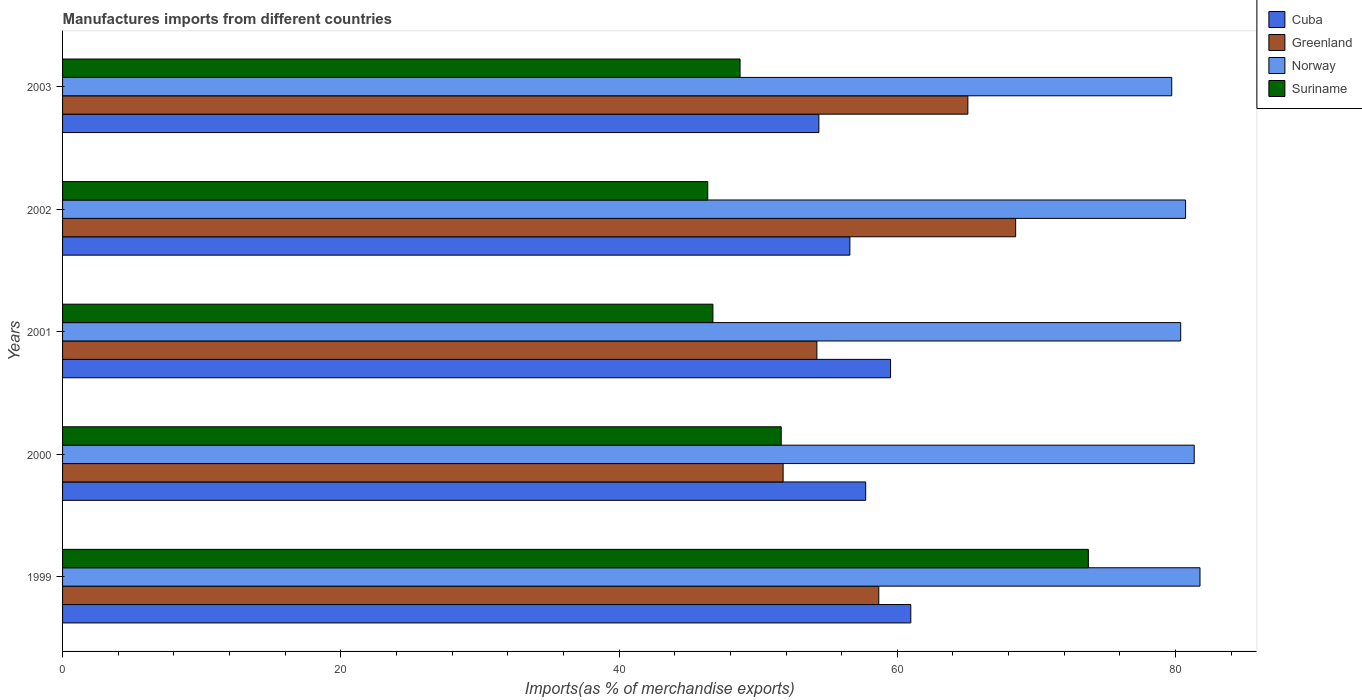Are the number of bars per tick equal to the number of legend labels?
Keep it short and to the point. Yes. How many bars are there on the 1st tick from the top?
Your answer should be very brief. 4. How many bars are there on the 2nd tick from the bottom?
Make the answer very short. 4. What is the label of the 5th group of bars from the top?
Ensure brevity in your answer.  1999. In how many cases, is the number of bars for a given year not equal to the number of legend labels?
Make the answer very short. 0. What is the percentage of imports to different countries in Cuba in 2002?
Keep it short and to the point. 56.59. Across all years, what is the maximum percentage of imports to different countries in Norway?
Ensure brevity in your answer.  81.75. Across all years, what is the minimum percentage of imports to different countries in Cuba?
Your answer should be compact. 54.36. In which year was the percentage of imports to different countries in Cuba maximum?
Keep it short and to the point. 1999. In which year was the percentage of imports to different countries in Cuba minimum?
Ensure brevity in your answer.  2003. What is the total percentage of imports to different countries in Suriname in the graph?
Make the answer very short. 267.2. What is the difference between the percentage of imports to different countries in Suriname in 2002 and that in 2003?
Your answer should be compact. -2.32. What is the difference between the percentage of imports to different countries in Greenland in 2000 and the percentage of imports to different countries in Norway in 2003?
Ensure brevity in your answer.  -27.93. What is the average percentage of imports to different countries in Suriname per year?
Offer a very short reply. 53.44. In the year 2002, what is the difference between the percentage of imports to different countries in Norway and percentage of imports to different countries in Greenland?
Make the answer very short. 12.21. In how many years, is the percentage of imports to different countries in Norway greater than 64 %?
Offer a terse response. 5. What is the ratio of the percentage of imports to different countries in Suriname in 1999 to that in 2000?
Offer a very short reply. 1.43. Is the difference between the percentage of imports to different countries in Norway in 1999 and 2003 greater than the difference between the percentage of imports to different countries in Greenland in 1999 and 2003?
Give a very brief answer. Yes. What is the difference between the highest and the second highest percentage of imports to different countries in Norway?
Keep it short and to the point. 0.41. What is the difference between the highest and the lowest percentage of imports to different countries in Cuba?
Keep it short and to the point. 6.61. What does the 4th bar from the top in 2001 represents?
Provide a short and direct response. Cuba. What does the 3rd bar from the bottom in 1999 represents?
Make the answer very short. Norway. Is it the case that in every year, the sum of the percentage of imports to different countries in Cuba and percentage of imports to different countries in Suriname is greater than the percentage of imports to different countries in Norway?
Make the answer very short. Yes. How many years are there in the graph?
Keep it short and to the point. 5. What is the difference between two consecutive major ticks on the X-axis?
Ensure brevity in your answer.  20. Are the values on the major ticks of X-axis written in scientific E-notation?
Offer a terse response. No. Does the graph contain any zero values?
Provide a succinct answer. No. How many legend labels are there?
Provide a short and direct response. 4. How are the legend labels stacked?
Offer a terse response. Vertical. What is the title of the graph?
Your answer should be compact. Manufactures imports from different countries. What is the label or title of the X-axis?
Keep it short and to the point. Imports(as % of merchandise exports). What is the Imports(as % of merchandise exports) of Cuba in 1999?
Your answer should be very brief. 60.97. What is the Imports(as % of merchandise exports) in Greenland in 1999?
Keep it short and to the point. 58.67. What is the Imports(as % of merchandise exports) of Norway in 1999?
Give a very brief answer. 81.75. What is the Imports(as % of merchandise exports) in Suriname in 1999?
Provide a short and direct response. 73.73. What is the Imports(as % of merchandise exports) of Cuba in 2000?
Provide a succinct answer. 57.72. What is the Imports(as % of merchandise exports) of Greenland in 2000?
Provide a succinct answer. 51.79. What is the Imports(as % of merchandise exports) of Norway in 2000?
Offer a very short reply. 81.34. What is the Imports(as % of merchandise exports) of Suriname in 2000?
Provide a short and direct response. 51.65. What is the Imports(as % of merchandise exports) of Cuba in 2001?
Offer a very short reply. 59.51. What is the Imports(as % of merchandise exports) in Greenland in 2001?
Make the answer very short. 54.22. What is the Imports(as % of merchandise exports) of Norway in 2001?
Offer a terse response. 80.37. What is the Imports(as % of merchandise exports) in Suriname in 2001?
Offer a terse response. 46.74. What is the Imports(as % of merchandise exports) of Cuba in 2002?
Keep it short and to the point. 56.59. What is the Imports(as % of merchandise exports) in Greenland in 2002?
Ensure brevity in your answer.  68.5. What is the Imports(as % of merchandise exports) in Norway in 2002?
Your answer should be very brief. 80.72. What is the Imports(as % of merchandise exports) in Suriname in 2002?
Keep it short and to the point. 46.37. What is the Imports(as % of merchandise exports) in Cuba in 2003?
Provide a short and direct response. 54.36. What is the Imports(as % of merchandise exports) of Greenland in 2003?
Offer a terse response. 65.07. What is the Imports(as % of merchandise exports) of Norway in 2003?
Offer a very short reply. 79.72. What is the Imports(as % of merchandise exports) in Suriname in 2003?
Keep it short and to the point. 48.7. Across all years, what is the maximum Imports(as % of merchandise exports) in Cuba?
Offer a terse response. 60.97. Across all years, what is the maximum Imports(as % of merchandise exports) in Greenland?
Give a very brief answer. 68.5. Across all years, what is the maximum Imports(as % of merchandise exports) of Norway?
Give a very brief answer. 81.75. Across all years, what is the maximum Imports(as % of merchandise exports) in Suriname?
Ensure brevity in your answer.  73.73. Across all years, what is the minimum Imports(as % of merchandise exports) in Cuba?
Provide a short and direct response. 54.36. Across all years, what is the minimum Imports(as % of merchandise exports) in Greenland?
Your answer should be very brief. 51.79. Across all years, what is the minimum Imports(as % of merchandise exports) in Norway?
Ensure brevity in your answer.  79.72. Across all years, what is the minimum Imports(as % of merchandise exports) in Suriname?
Make the answer very short. 46.37. What is the total Imports(as % of merchandise exports) of Cuba in the graph?
Make the answer very short. 289.15. What is the total Imports(as % of merchandise exports) in Greenland in the graph?
Provide a succinct answer. 298.25. What is the total Imports(as % of merchandise exports) in Norway in the graph?
Your response must be concise. 403.9. What is the total Imports(as % of merchandise exports) of Suriname in the graph?
Keep it short and to the point. 267.2. What is the difference between the Imports(as % of merchandise exports) of Cuba in 1999 and that in 2000?
Give a very brief answer. 3.24. What is the difference between the Imports(as % of merchandise exports) in Greenland in 1999 and that in 2000?
Your answer should be very brief. 6.88. What is the difference between the Imports(as % of merchandise exports) of Norway in 1999 and that in 2000?
Keep it short and to the point. 0.41. What is the difference between the Imports(as % of merchandise exports) of Suriname in 1999 and that in 2000?
Make the answer very short. 22.08. What is the difference between the Imports(as % of merchandise exports) in Cuba in 1999 and that in 2001?
Your answer should be compact. 1.45. What is the difference between the Imports(as % of merchandise exports) in Greenland in 1999 and that in 2001?
Give a very brief answer. 4.45. What is the difference between the Imports(as % of merchandise exports) in Norway in 1999 and that in 2001?
Give a very brief answer. 1.39. What is the difference between the Imports(as % of merchandise exports) in Suriname in 1999 and that in 2001?
Make the answer very short. 26.99. What is the difference between the Imports(as % of merchandise exports) in Cuba in 1999 and that in 2002?
Make the answer very short. 4.38. What is the difference between the Imports(as % of merchandise exports) in Greenland in 1999 and that in 2002?
Give a very brief answer. -9.84. What is the difference between the Imports(as % of merchandise exports) in Norway in 1999 and that in 2002?
Offer a terse response. 1.04. What is the difference between the Imports(as % of merchandise exports) in Suriname in 1999 and that in 2002?
Keep it short and to the point. 27.36. What is the difference between the Imports(as % of merchandise exports) in Cuba in 1999 and that in 2003?
Offer a very short reply. 6.61. What is the difference between the Imports(as % of merchandise exports) of Greenland in 1999 and that in 2003?
Make the answer very short. -6.4. What is the difference between the Imports(as % of merchandise exports) of Norway in 1999 and that in 2003?
Offer a very short reply. 2.03. What is the difference between the Imports(as % of merchandise exports) in Suriname in 1999 and that in 2003?
Give a very brief answer. 25.03. What is the difference between the Imports(as % of merchandise exports) in Cuba in 2000 and that in 2001?
Keep it short and to the point. -1.79. What is the difference between the Imports(as % of merchandise exports) of Greenland in 2000 and that in 2001?
Your response must be concise. -2.43. What is the difference between the Imports(as % of merchandise exports) in Norway in 2000 and that in 2001?
Give a very brief answer. 0.97. What is the difference between the Imports(as % of merchandise exports) of Suriname in 2000 and that in 2001?
Keep it short and to the point. 4.91. What is the difference between the Imports(as % of merchandise exports) of Cuba in 2000 and that in 2002?
Give a very brief answer. 1.14. What is the difference between the Imports(as % of merchandise exports) of Greenland in 2000 and that in 2002?
Provide a short and direct response. -16.71. What is the difference between the Imports(as % of merchandise exports) in Norway in 2000 and that in 2002?
Provide a succinct answer. 0.62. What is the difference between the Imports(as % of merchandise exports) of Suriname in 2000 and that in 2002?
Offer a terse response. 5.28. What is the difference between the Imports(as % of merchandise exports) of Cuba in 2000 and that in 2003?
Give a very brief answer. 3.36. What is the difference between the Imports(as % of merchandise exports) in Greenland in 2000 and that in 2003?
Your answer should be very brief. -13.28. What is the difference between the Imports(as % of merchandise exports) in Norway in 2000 and that in 2003?
Your answer should be very brief. 1.62. What is the difference between the Imports(as % of merchandise exports) of Suriname in 2000 and that in 2003?
Your response must be concise. 2.96. What is the difference between the Imports(as % of merchandise exports) in Cuba in 2001 and that in 2002?
Your response must be concise. 2.93. What is the difference between the Imports(as % of merchandise exports) in Greenland in 2001 and that in 2002?
Offer a very short reply. -14.29. What is the difference between the Imports(as % of merchandise exports) of Norway in 2001 and that in 2002?
Make the answer very short. -0.35. What is the difference between the Imports(as % of merchandise exports) in Suriname in 2001 and that in 2002?
Offer a terse response. 0.37. What is the difference between the Imports(as % of merchandise exports) in Cuba in 2001 and that in 2003?
Offer a very short reply. 5.15. What is the difference between the Imports(as % of merchandise exports) in Greenland in 2001 and that in 2003?
Give a very brief answer. -10.85. What is the difference between the Imports(as % of merchandise exports) of Norway in 2001 and that in 2003?
Keep it short and to the point. 0.64. What is the difference between the Imports(as % of merchandise exports) of Suriname in 2001 and that in 2003?
Your answer should be compact. -1.95. What is the difference between the Imports(as % of merchandise exports) of Cuba in 2002 and that in 2003?
Your answer should be compact. 2.23. What is the difference between the Imports(as % of merchandise exports) in Greenland in 2002 and that in 2003?
Give a very brief answer. 3.44. What is the difference between the Imports(as % of merchandise exports) in Suriname in 2002 and that in 2003?
Your answer should be compact. -2.32. What is the difference between the Imports(as % of merchandise exports) in Cuba in 1999 and the Imports(as % of merchandise exports) in Greenland in 2000?
Keep it short and to the point. 9.18. What is the difference between the Imports(as % of merchandise exports) of Cuba in 1999 and the Imports(as % of merchandise exports) of Norway in 2000?
Ensure brevity in your answer.  -20.37. What is the difference between the Imports(as % of merchandise exports) in Cuba in 1999 and the Imports(as % of merchandise exports) in Suriname in 2000?
Provide a short and direct response. 9.31. What is the difference between the Imports(as % of merchandise exports) of Greenland in 1999 and the Imports(as % of merchandise exports) of Norway in 2000?
Provide a succinct answer. -22.67. What is the difference between the Imports(as % of merchandise exports) in Greenland in 1999 and the Imports(as % of merchandise exports) in Suriname in 2000?
Provide a short and direct response. 7.01. What is the difference between the Imports(as % of merchandise exports) in Norway in 1999 and the Imports(as % of merchandise exports) in Suriname in 2000?
Keep it short and to the point. 30.1. What is the difference between the Imports(as % of merchandise exports) of Cuba in 1999 and the Imports(as % of merchandise exports) of Greenland in 2001?
Keep it short and to the point. 6.75. What is the difference between the Imports(as % of merchandise exports) of Cuba in 1999 and the Imports(as % of merchandise exports) of Norway in 2001?
Your answer should be very brief. -19.4. What is the difference between the Imports(as % of merchandise exports) of Cuba in 1999 and the Imports(as % of merchandise exports) of Suriname in 2001?
Provide a succinct answer. 14.22. What is the difference between the Imports(as % of merchandise exports) of Greenland in 1999 and the Imports(as % of merchandise exports) of Norway in 2001?
Provide a succinct answer. -21.7. What is the difference between the Imports(as % of merchandise exports) in Greenland in 1999 and the Imports(as % of merchandise exports) in Suriname in 2001?
Offer a terse response. 11.92. What is the difference between the Imports(as % of merchandise exports) in Norway in 1999 and the Imports(as % of merchandise exports) in Suriname in 2001?
Give a very brief answer. 35.01. What is the difference between the Imports(as % of merchandise exports) of Cuba in 1999 and the Imports(as % of merchandise exports) of Greenland in 2002?
Give a very brief answer. -7.54. What is the difference between the Imports(as % of merchandise exports) in Cuba in 1999 and the Imports(as % of merchandise exports) in Norway in 2002?
Ensure brevity in your answer.  -19.75. What is the difference between the Imports(as % of merchandise exports) of Cuba in 1999 and the Imports(as % of merchandise exports) of Suriname in 2002?
Offer a very short reply. 14.59. What is the difference between the Imports(as % of merchandise exports) in Greenland in 1999 and the Imports(as % of merchandise exports) in Norway in 2002?
Give a very brief answer. -22.05. What is the difference between the Imports(as % of merchandise exports) in Greenland in 1999 and the Imports(as % of merchandise exports) in Suriname in 2002?
Offer a terse response. 12.29. What is the difference between the Imports(as % of merchandise exports) of Norway in 1999 and the Imports(as % of merchandise exports) of Suriname in 2002?
Offer a terse response. 35.38. What is the difference between the Imports(as % of merchandise exports) of Cuba in 1999 and the Imports(as % of merchandise exports) of Greenland in 2003?
Make the answer very short. -4.1. What is the difference between the Imports(as % of merchandise exports) of Cuba in 1999 and the Imports(as % of merchandise exports) of Norway in 2003?
Provide a short and direct response. -18.76. What is the difference between the Imports(as % of merchandise exports) in Cuba in 1999 and the Imports(as % of merchandise exports) in Suriname in 2003?
Your answer should be compact. 12.27. What is the difference between the Imports(as % of merchandise exports) of Greenland in 1999 and the Imports(as % of merchandise exports) of Norway in 2003?
Your response must be concise. -21.06. What is the difference between the Imports(as % of merchandise exports) of Greenland in 1999 and the Imports(as % of merchandise exports) of Suriname in 2003?
Offer a terse response. 9.97. What is the difference between the Imports(as % of merchandise exports) of Norway in 1999 and the Imports(as % of merchandise exports) of Suriname in 2003?
Give a very brief answer. 33.06. What is the difference between the Imports(as % of merchandise exports) of Cuba in 2000 and the Imports(as % of merchandise exports) of Greenland in 2001?
Offer a very short reply. 3.51. What is the difference between the Imports(as % of merchandise exports) of Cuba in 2000 and the Imports(as % of merchandise exports) of Norway in 2001?
Give a very brief answer. -22.64. What is the difference between the Imports(as % of merchandise exports) of Cuba in 2000 and the Imports(as % of merchandise exports) of Suriname in 2001?
Give a very brief answer. 10.98. What is the difference between the Imports(as % of merchandise exports) in Greenland in 2000 and the Imports(as % of merchandise exports) in Norway in 2001?
Give a very brief answer. -28.58. What is the difference between the Imports(as % of merchandise exports) of Greenland in 2000 and the Imports(as % of merchandise exports) of Suriname in 2001?
Ensure brevity in your answer.  5.05. What is the difference between the Imports(as % of merchandise exports) of Norway in 2000 and the Imports(as % of merchandise exports) of Suriname in 2001?
Provide a succinct answer. 34.6. What is the difference between the Imports(as % of merchandise exports) of Cuba in 2000 and the Imports(as % of merchandise exports) of Greenland in 2002?
Your response must be concise. -10.78. What is the difference between the Imports(as % of merchandise exports) of Cuba in 2000 and the Imports(as % of merchandise exports) of Norway in 2002?
Your answer should be compact. -22.99. What is the difference between the Imports(as % of merchandise exports) of Cuba in 2000 and the Imports(as % of merchandise exports) of Suriname in 2002?
Your response must be concise. 11.35. What is the difference between the Imports(as % of merchandise exports) of Greenland in 2000 and the Imports(as % of merchandise exports) of Norway in 2002?
Provide a succinct answer. -28.93. What is the difference between the Imports(as % of merchandise exports) in Greenland in 2000 and the Imports(as % of merchandise exports) in Suriname in 2002?
Keep it short and to the point. 5.42. What is the difference between the Imports(as % of merchandise exports) of Norway in 2000 and the Imports(as % of merchandise exports) of Suriname in 2002?
Provide a succinct answer. 34.97. What is the difference between the Imports(as % of merchandise exports) in Cuba in 2000 and the Imports(as % of merchandise exports) in Greenland in 2003?
Provide a short and direct response. -7.34. What is the difference between the Imports(as % of merchandise exports) of Cuba in 2000 and the Imports(as % of merchandise exports) of Norway in 2003?
Ensure brevity in your answer.  -22. What is the difference between the Imports(as % of merchandise exports) in Cuba in 2000 and the Imports(as % of merchandise exports) in Suriname in 2003?
Make the answer very short. 9.03. What is the difference between the Imports(as % of merchandise exports) in Greenland in 2000 and the Imports(as % of merchandise exports) in Norway in 2003?
Ensure brevity in your answer.  -27.93. What is the difference between the Imports(as % of merchandise exports) of Greenland in 2000 and the Imports(as % of merchandise exports) of Suriname in 2003?
Keep it short and to the point. 3.09. What is the difference between the Imports(as % of merchandise exports) of Norway in 2000 and the Imports(as % of merchandise exports) of Suriname in 2003?
Make the answer very short. 32.64. What is the difference between the Imports(as % of merchandise exports) in Cuba in 2001 and the Imports(as % of merchandise exports) in Greenland in 2002?
Your answer should be compact. -8.99. What is the difference between the Imports(as % of merchandise exports) in Cuba in 2001 and the Imports(as % of merchandise exports) in Norway in 2002?
Provide a succinct answer. -21.2. What is the difference between the Imports(as % of merchandise exports) of Cuba in 2001 and the Imports(as % of merchandise exports) of Suriname in 2002?
Give a very brief answer. 13.14. What is the difference between the Imports(as % of merchandise exports) of Greenland in 2001 and the Imports(as % of merchandise exports) of Norway in 2002?
Your answer should be very brief. -26.5. What is the difference between the Imports(as % of merchandise exports) of Greenland in 2001 and the Imports(as % of merchandise exports) of Suriname in 2002?
Your response must be concise. 7.84. What is the difference between the Imports(as % of merchandise exports) in Norway in 2001 and the Imports(as % of merchandise exports) in Suriname in 2002?
Make the answer very short. 33.99. What is the difference between the Imports(as % of merchandise exports) of Cuba in 2001 and the Imports(as % of merchandise exports) of Greenland in 2003?
Keep it short and to the point. -5.56. What is the difference between the Imports(as % of merchandise exports) of Cuba in 2001 and the Imports(as % of merchandise exports) of Norway in 2003?
Make the answer very short. -20.21. What is the difference between the Imports(as % of merchandise exports) of Cuba in 2001 and the Imports(as % of merchandise exports) of Suriname in 2003?
Your answer should be very brief. 10.82. What is the difference between the Imports(as % of merchandise exports) in Greenland in 2001 and the Imports(as % of merchandise exports) in Norway in 2003?
Your answer should be compact. -25.51. What is the difference between the Imports(as % of merchandise exports) in Greenland in 2001 and the Imports(as % of merchandise exports) in Suriname in 2003?
Provide a short and direct response. 5.52. What is the difference between the Imports(as % of merchandise exports) in Norway in 2001 and the Imports(as % of merchandise exports) in Suriname in 2003?
Provide a succinct answer. 31.67. What is the difference between the Imports(as % of merchandise exports) in Cuba in 2002 and the Imports(as % of merchandise exports) in Greenland in 2003?
Give a very brief answer. -8.48. What is the difference between the Imports(as % of merchandise exports) of Cuba in 2002 and the Imports(as % of merchandise exports) of Norway in 2003?
Provide a short and direct response. -23.13. What is the difference between the Imports(as % of merchandise exports) in Cuba in 2002 and the Imports(as % of merchandise exports) in Suriname in 2003?
Provide a succinct answer. 7.89. What is the difference between the Imports(as % of merchandise exports) in Greenland in 2002 and the Imports(as % of merchandise exports) in Norway in 2003?
Offer a very short reply. -11.22. What is the difference between the Imports(as % of merchandise exports) of Greenland in 2002 and the Imports(as % of merchandise exports) of Suriname in 2003?
Your answer should be very brief. 19.81. What is the difference between the Imports(as % of merchandise exports) in Norway in 2002 and the Imports(as % of merchandise exports) in Suriname in 2003?
Make the answer very short. 32.02. What is the average Imports(as % of merchandise exports) of Cuba per year?
Provide a succinct answer. 57.83. What is the average Imports(as % of merchandise exports) in Greenland per year?
Provide a succinct answer. 59.65. What is the average Imports(as % of merchandise exports) of Norway per year?
Make the answer very short. 80.78. What is the average Imports(as % of merchandise exports) of Suriname per year?
Your response must be concise. 53.44. In the year 1999, what is the difference between the Imports(as % of merchandise exports) of Cuba and Imports(as % of merchandise exports) of Greenland?
Give a very brief answer. 2.3. In the year 1999, what is the difference between the Imports(as % of merchandise exports) in Cuba and Imports(as % of merchandise exports) in Norway?
Your response must be concise. -20.79. In the year 1999, what is the difference between the Imports(as % of merchandise exports) of Cuba and Imports(as % of merchandise exports) of Suriname?
Provide a succinct answer. -12.76. In the year 1999, what is the difference between the Imports(as % of merchandise exports) of Greenland and Imports(as % of merchandise exports) of Norway?
Your response must be concise. -23.09. In the year 1999, what is the difference between the Imports(as % of merchandise exports) in Greenland and Imports(as % of merchandise exports) in Suriname?
Offer a very short reply. -15.06. In the year 1999, what is the difference between the Imports(as % of merchandise exports) of Norway and Imports(as % of merchandise exports) of Suriname?
Offer a terse response. 8.02. In the year 2000, what is the difference between the Imports(as % of merchandise exports) of Cuba and Imports(as % of merchandise exports) of Greenland?
Make the answer very short. 5.93. In the year 2000, what is the difference between the Imports(as % of merchandise exports) in Cuba and Imports(as % of merchandise exports) in Norway?
Offer a terse response. -23.62. In the year 2000, what is the difference between the Imports(as % of merchandise exports) of Cuba and Imports(as % of merchandise exports) of Suriname?
Your response must be concise. 6.07. In the year 2000, what is the difference between the Imports(as % of merchandise exports) of Greenland and Imports(as % of merchandise exports) of Norway?
Give a very brief answer. -29.55. In the year 2000, what is the difference between the Imports(as % of merchandise exports) in Greenland and Imports(as % of merchandise exports) in Suriname?
Make the answer very short. 0.14. In the year 2000, what is the difference between the Imports(as % of merchandise exports) in Norway and Imports(as % of merchandise exports) in Suriname?
Provide a short and direct response. 29.69. In the year 2001, what is the difference between the Imports(as % of merchandise exports) of Cuba and Imports(as % of merchandise exports) of Greenland?
Your response must be concise. 5.3. In the year 2001, what is the difference between the Imports(as % of merchandise exports) of Cuba and Imports(as % of merchandise exports) of Norway?
Your answer should be compact. -20.85. In the year 2001, what is the difference between the Imports(as % of merchandise exports) in Cuba and Imports(as % of merchandise exports) in Suriname?
Keep it short and to the point. 12.77. In the year 2001, what is the difference between the Imports(as % of merchandise exports) of Greenland and Imports(as % of merchandise exports) of Norway?
Provide a succinct answer. -26.15. In the year 2001, what is the difference between the Imports(as % of merchandise exports) of Greenland and Imports(as % of merchandise exports) of Suriname?
Offer a terse response. 7.47. In the year 2001, what is the difference between the Imports(as % of merchandise exports) of Norway and Imports(as % of merchandise exports) of Suriname?
Keep it short and to the point. 33.62. In the year 2002, what is the difference between the Imports(as % of merchandise exports) in Cuba and Imports(as % of merchandise exports) in Greenland?
Offer a terse response. -11.92. In the year 2002, what is the difference between the Imports(as % of merchandise exports) in Cuba and Imports(as % of merchandise exports) in Norway?
Your answer should be very brief. -24.13. In the year 2002, what is the difference between the Imports(as % of merchandise exports) of Cuba and Imports(as % of merchandise exports) of Suriname?
Offer a very short reply. 10.21. In the year 2002, what is the difference between the Imports(as % of merchandise exports) in Greenland and Imports(as % of merchandise exports) in Norway?
Your answer should be compact. -12.21. In the year 2002, what is the difference between the Imports(as % of merchandise exports) of Greenland and Imports(as % of merchandise exports) of Suriname?
Your answer should be very brief. 22.13. In the year 2002, what is the difference between the Imports(as % of merchandise exports) in Norway and Imports(as % of merchandise exports) in Suriname?
Make the answer very short. 34.34. In the year 2003, what is the difference between the Imports(as % of merchandise exports) of Cuba and Imports(as % of merchandise exports) of Greenland?
Your answer should be compact. -10.71. In the year 2003, what is the difference between the Imports(as % of merchandise exports) of Cuba and Imports(as % of merchandise exports) of Norway?
Keep it short and to the point. -25.36. In the year 2003, what is the difference between the Imports(as % of merchandise exports) in Cuba and Imports(as % of merchandise exports) in Suriname?
Provide a succinct answer. 5.66. In the year 2003, what is the difference between the Imports(as % of merchandise exports) of Greenland and Imports(as % of merchandise exports) of Norway?
Your response must be concise. -14.65. In the year 2003, what is the difference between the Imports(as % of merchandise exports) in Greenland and Imports(as % of merchandise exports) in Suriname?
Provide a short and direct response. 16.37. In the year 2003, what is the difference between the Imports(as % of merchandise exports) of Norway and Imports(as % of merchandise exports) of Suriname?
Your answer should be very brief. 31.03. What is the ratio of the Imports(as % of merchandise exports) of Cuba in 1999 to that in 2000?
Provide a short and direct response. 1.06. What is the ratio of the Imports(as % of merchandise exports) in Greenland in 1999 to that in 2000?
Give a very brief answer. 1.13. What is the ratio of the Imports(as % of merchandise exports) in Norway in 1999 to that in 2000?
Your answer should be compact. 1.01. What is the ratio of the Imports(as % of merchandise exports) in Suriname in 1999 to that in 2000?
Keep it short and to the point. 1.43. What is the ratio of the Imports(as % of merchandise exports) of Cuba in 1999 to that in 2001?
Offer a terse response. 1.02. What is the ratio of the Imports(as % of merchandise exports) of Greenland in 1999 to that in 2001?
Provide a short and direct response. 1.08. What is the ratio of the Imports(as % of merchandise exports) in Norway in 1999 to that in 2001?
Make the answer very short. 1.02. What is the ratio of the Imports(as % of merchandise exports) in Suriname in 1999 to that in 2001?
Your answer should be compact. 1.58. What is the ratio of the Imports(as % of merchandise exports) in Cuba in 1999 to that in 2002?
Offer a very short reply. 1.08. What is the ratio of the Imports(as % of merchandise exports) of Greenland in 1999 to that in 2002?
Offer a very short reply. 0.86. What is the ratio of the Imports(as % of merchandise exports) in Norway in 1999 to that in 2002?
Your answer should be compact. 1.01. What is the ratio of the Imports(as % of merchandise exports) in Suriname in 1999 to that in 2002?
Your answer should be compact. 1.59. What is the ratio of the Imports(as % of merchandise exports) in Cuba in 1999 to that in 2003?
Your answer should be very brief. 1.12. What is the ratio of the Imports(as % of merchandise exports) of Greenland in 1999 to that in 2003?
Keep it short and to the point. 0.9. What is the ratio of the Imports(as % of merchandise exports) of Norway in 1999 to that in 2003?
Keep it short and to the point. 1.03. What is the ratio of the Imports(as % of merchandise exports) of Suriname in 1999 to that in 2003?
Your answer should be compact. 1.51. What is the ratio of the Imports(as % of merchandise exports) in Cuba in 2000 to that in 2001?
Provide a succinct answer. 0.97. What is the ratio of the Imports(as % of merchandise exports) in Greenland in 2000 to that in 2001?
Offer a very short reply. 0.96. What is the ratio of the Imports(as % of merchandise exports) in Norway in 2000 to that in 2001?
Your answer should be compact. 1.01. What is the ratio of the Imports(as % of merchandise exports) of Suriname in 2000 to that in 2001?
Offer a very short reply. 1.11. What is the ratio of the Imports(as % of merchandise exports) in Cuba in 2000 to that in 2002?
Your response must be concise. 1.02. What is the ratio of the Imports(as % of merchandise exports) in Greenland in 2000 to that in 2002?
Offer a very short reply. 0.76. What is the ratio of the Imports(as % of merchandise exports) of Norway in 2000 to that in 2002?
Your answer should be very brief. 1.01. What is the ratio of the Imports(as % of merchandise exports) in Suriname in 2000 to that in 2002?
Offer a terse response. 1.11. What is the ratio of the Imports(as % of merchandise exports) in Cuba in 2000 to that in 2003?
Give a very brief answer. 1.06. What is the ratio of the Imports(as % of merchandise exports) in Greenland in 2000 to that in 2003?
Give a very brief answer. 0.8. What is the ratio of the Imports(as % of merchandise exports) of Norway in 2000 to that in 2003?
Provide a short and direct response. 1.02. What is the ratio of the Imports(as % of merchandise exports) of Suriname in 2000 to that in 2003?
Your answer should be compact. 1.06. What is the ratio of the Imports(as % of merchandise exports) in Cuba in 2001 to that in 2002?
Make the answer very short. 1.05. What is the ratio of the Imports(as % of merchandise exports) of Greenland in 2001 to that in 2002?
Keep it short and to the point. 0.79. What is the ratio of the Imports(as % of merchandise exports) of Norway in 2001 to that in 2002?
Offer a terse response. 1. What is the ratio of the Imports(as % of merchandise exports) of Cuba in 2001 to that in 2003?
Keep it short and to the point. 1.09. What is the ratio of the Imports(as % of merchandise exports) in Greenland in 2001 to that in 2003?
Your response must be concise. 0.83. What is the ratio of the Imports(as % of merchandise exports) in Suriname in 2001 to that in 2003?
Offer a terse response. 0.96. What is the ratio of the Imports(as % of merchandise exports) of Cuba in 2002 to that in 2003?
Ensure brevity in your answer.  1.04. What is the ratio of the Imports(as % of merchandise exports) of Greenland in 2002 to that in 2003?
Provide a short and direct response. 1.05. What is the ratio of the Imports(as % of merchandise exports) of Norway in 2002 to that in 2003?
Your response must be concise. 1.01. What is the ratio of the Imports(as % of merchandise exports) in Suriname in 2002 to that in 2003?
Your response must be concise. 0.95. What is the difference between the highest and the second highest Imports(as % of merchandise exports) in Cuba?
Provide a short and direct response. 1.45. What is the difference between the highest and the second highest Imports(as % of merchandise exports) in Greenland?
Ensure brevity in your answer.  3.44. What is the difference between the highest and the second highest Imports(as % of merchandise exports) in Norway?
Give a very brief answer. 0.41. What is the difference between the highest and the second highest Imports(as % of merchandise exports) of Suriname?
Keep it short and to the point. 22.08. What is the difference between the highest and the lowest Imports(as % of merchandise exports) of Cuba?
Your answer should be very brief. 6.61. What is the difference between the highest and the lowest Imports(as % of merchandise exports) in Greenland?
Your answer should be very brief. 16.71. What is the difference between the highest and the lowest Imports(as % of merchandise exports) in Norway?
Provide a short and direct response. 2.03. What is the difference between the highest and the lowest Imports(as % of merchandise exports) of Suriname?
Your answer should be very brief. 27.36. 